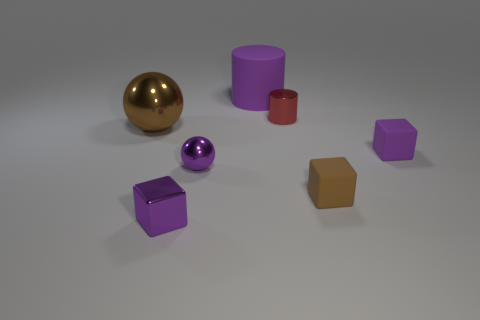What is the texture of the objects, and does lighting affect their appearance? The objects have various textures, with some having matte surfaces like the purple cubes, or glossy ones like the purple sphere. The lighting creates soft shadows and highlights that enhance the three-dimensional look of each object, and it indicates the texture by the way light reflects off those with glossy finishes compared to those with a matte finish. Can you explain the placement of these objects, does it suggest anything? The objects are arranged in an orderly yet dispersed pattern across the flat surface, suggesting a structured setting that's possibly designed for a display or a comparison of shapes, colors, and sizes. However, there's no inherent suggestion of movement or interaction among the objects. 